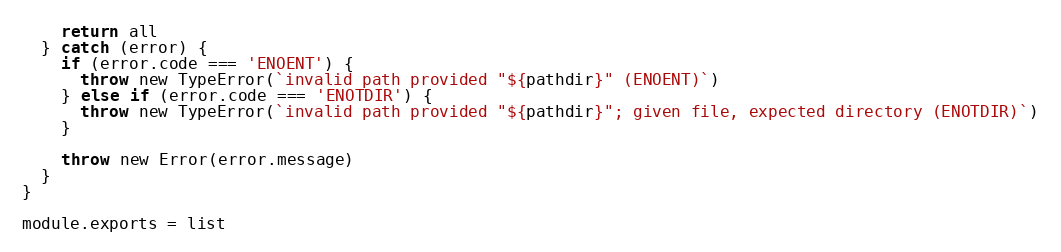Convert code to text. <code><loc_0><loc_0><loc_500><loc_500><_JavaScript_>
    return all
  } catch (error) {
    if (error.code === 'ENOENT') {
      throw new TypeError(`invalid path provided "${pathdir}" (ENOENT)`)
    } else if (error.code === 'ENOTDIR') {
      throw new TypeError(`invalid path provided "${pathdir}"; given file, expected directory (ENOTDIR)`)
    }

    throw new Error(error.message)
  }
}

module.exports = list
</code> 